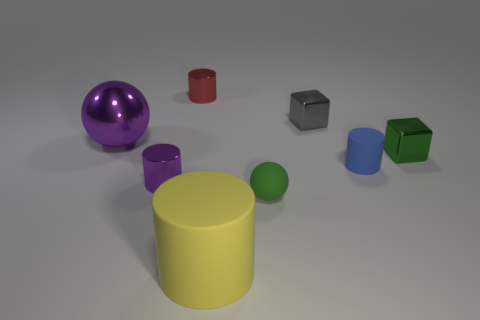What color is the big metal ball?
Give a very brief answer. Purple. Does the metal cylinder that is to the left of the red shiny object have the same color as the metallic sphere?
Your response must be concise. Yes. What number of other tiny spheres have the same color as the tiny matte ball?
Your response must be concise. 0. There is a purple object behind the green cube; is it the same shape as the green rubber thing?
Your response must be concise. Yes. Is the number of objects in front of the large purple metallic thing less than the number of objects that are in front of the tiny gray cube?
Make the answer very short. Yes. There is a green object on the left side of the tiny rubber cylinder; what is its material?
Your answer should be very brief. Rubber. What is the size of the object that is the same color as the large sphere?
Your answer should be very brief. Small. Is there a gray object of the same size as the matte sphere?
Keep it short and to the point. Yes. There is a big metallic thing; is it the same shape as the small green object in front of the purple metallic cylinder?
Make the answer very short. Yes. There is a rubber cylinder that is behind the tiny sphere; is its size the same as the ball that is left of the red object?
Your response must be concise. No. 